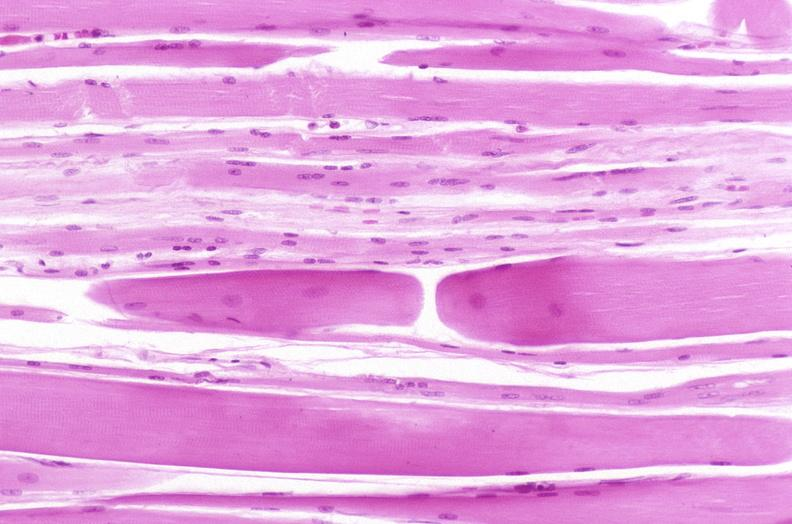what does this image show?
Answer the question using a single word or phrase. Skeletal muscle 